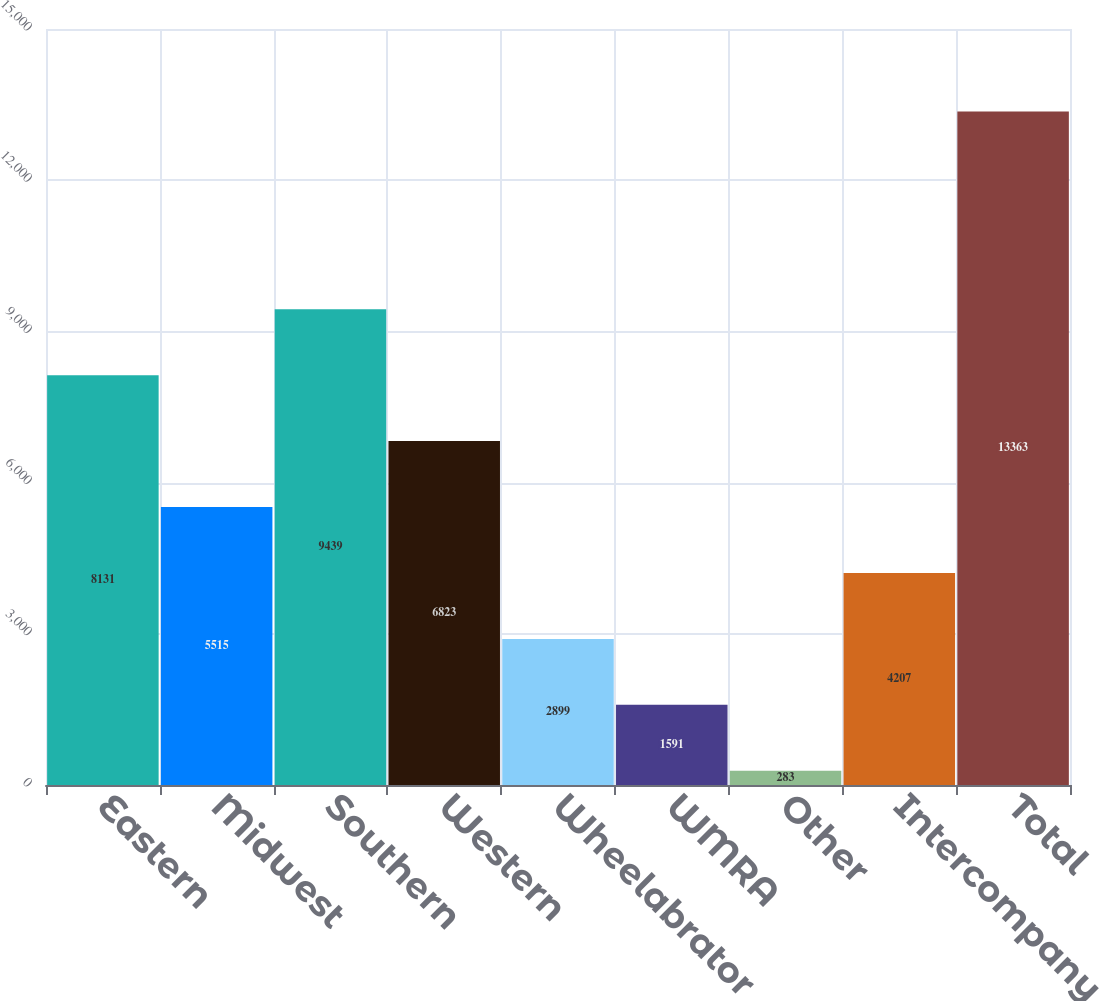Convert chart to OTSL. <chart><loc_0><loc_0><loc_500><loc_500><bar_chart><fcel>Eastern<fcel>Midwest<fcel>Southern<fcel>Western<fcel>Wheelabrator<fcel>WMRA<fcel>Other<fcel>Intercompany<fcel>Total<nl><fcel>8131<fcel>5515<fcel>9439<fcel>6823<fcel>2899<fcel>1591<fcel>283<fcel>4207<fcel>13363<nl></chart> 